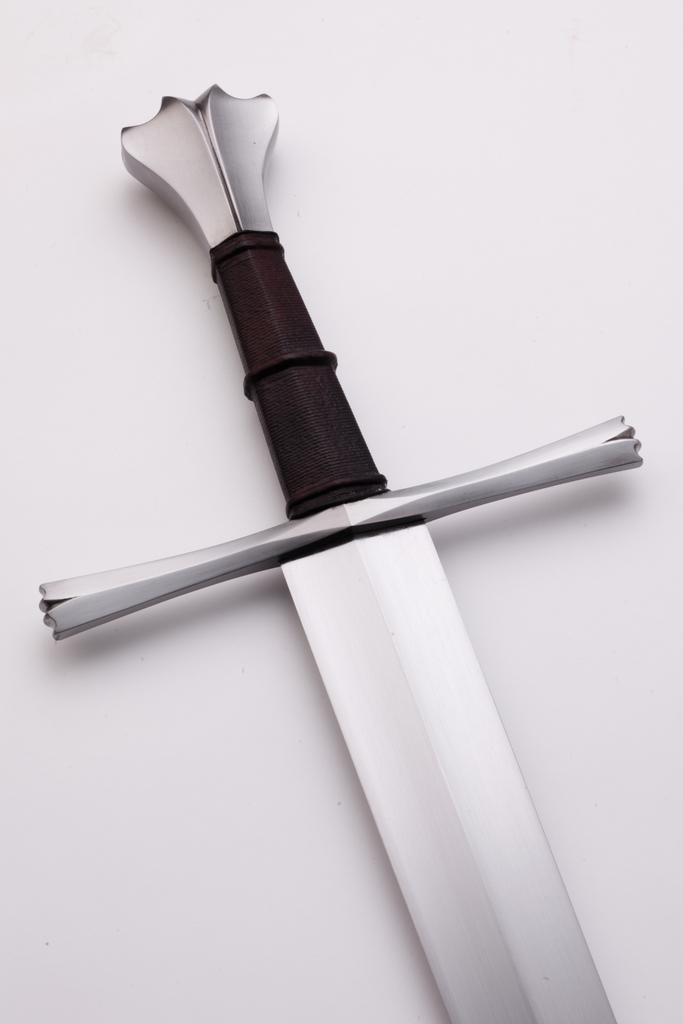What object can be seen in the image? There is a sword in the image. What color is the background of the image? The background of the image is white. Is there a kite flying in the background of the image? No, there is no kite present in the image. What type of shelter is visible in the image? There is no shelter, such as a tent, present in the image. 